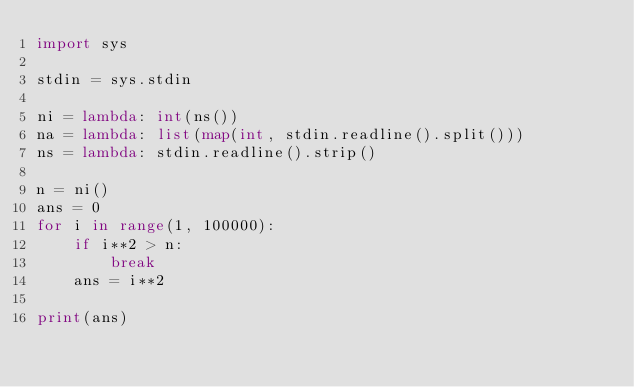Convert code to text. <code><loc_0><loc_0><loc_500><loc_500><_Python_>import sys

stdin = sys.stdin

ni = lambda: int(ns())
na = lambda: list(map(int, stdin.readline().split()))
ns = lambda: stdin.readline().strip()

n = ni()
ans = 0
for i in range(1, 100000):
    if i**2 > n:
        break
    ans = i**2

print(ans)
</code> 